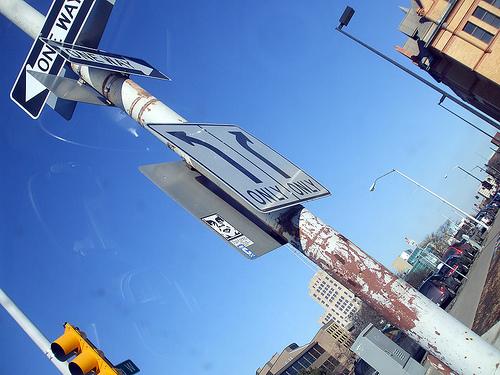How many signs are on the pole?
Give a very brief answer. 6. Are these one way streets?
Keep it brief. Yes. What kind of sign is this?
Give a very brief answer. Traffic. 